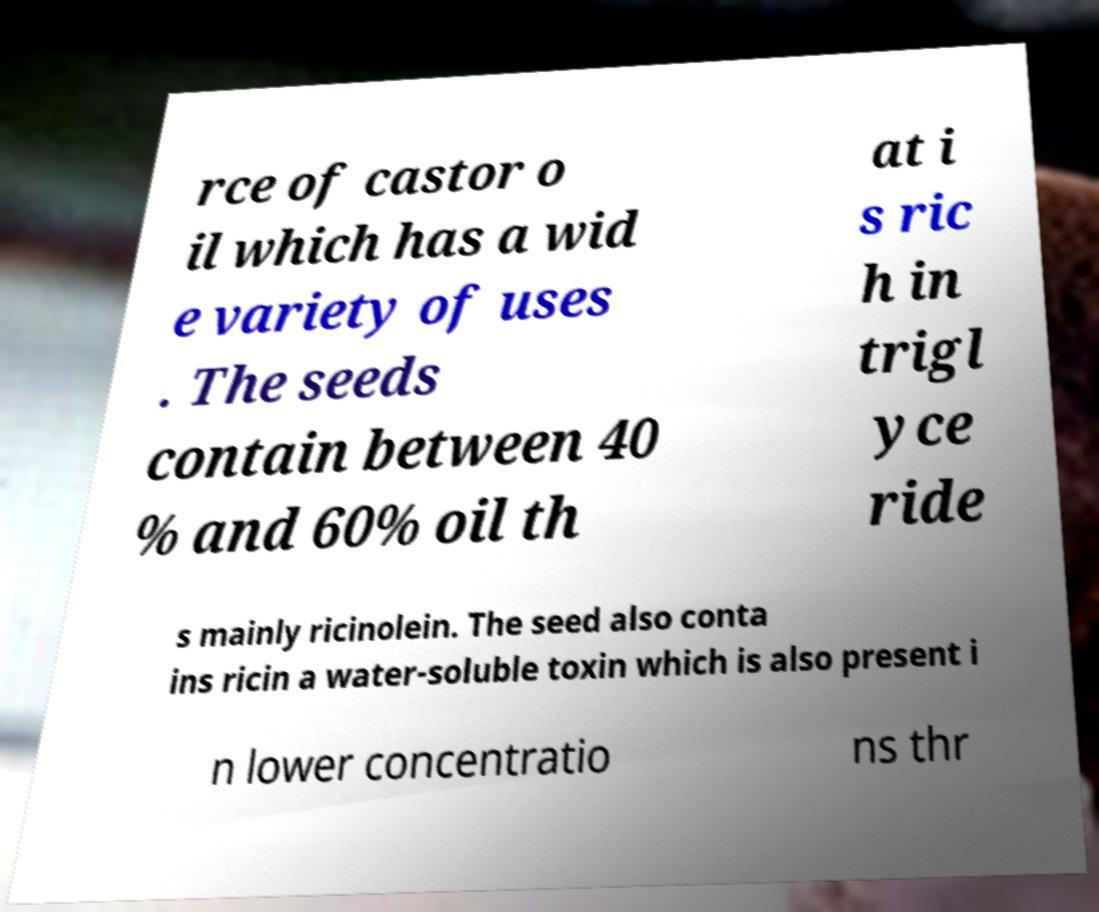Can you accurately transcribe the text from the provided image for me? rce of castor o il which has a wid e variety of uses . The seeds contain between 40 % and 60% oil th at i s ric h in trigl yce ride s mainly ricinolein. The seed also conta ins ricin a water-soluble toxin which is also present i n lower concentratio ns thr 